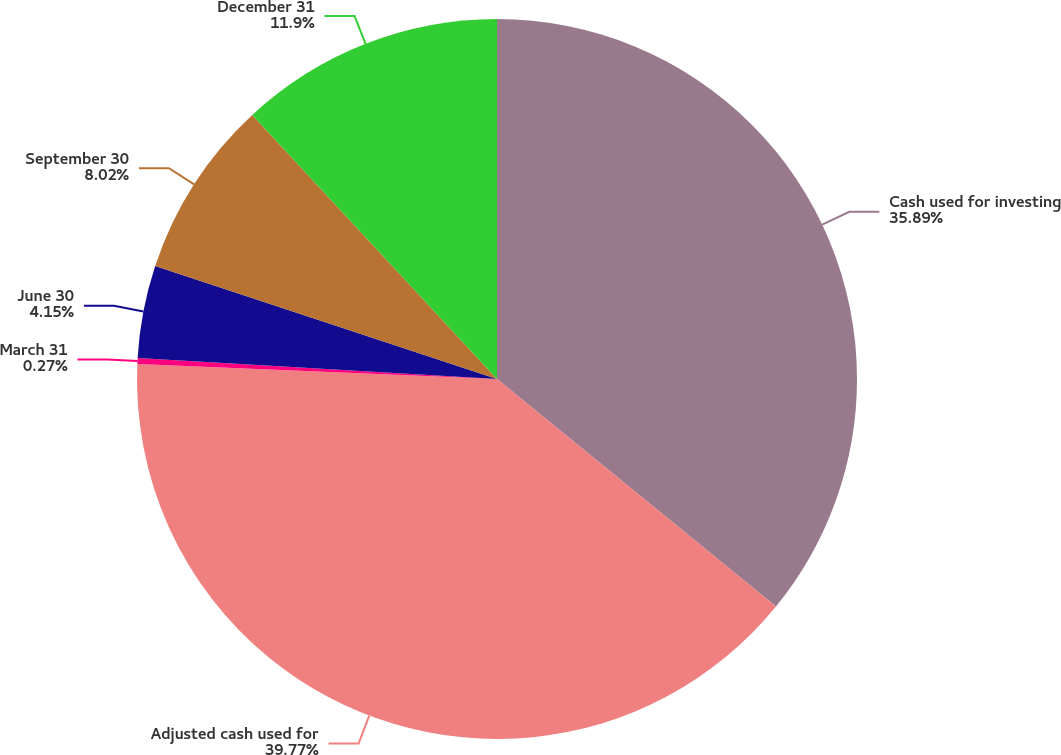Convert chart to OTSL. <chart><loc_0><loc_0><loc_500><loc_500><pie_chart><fcel>Cash used for investing<fcel>Adjusted cash used for<fcel>March 31<fcel>June 30<fcel>September 30<fcel>December 31<nl><fcel>35.89%<fcel>39.77%<fcel>0.27%<fcel>4.15%<fcel>8.02%<fcel>11.9%<nl></chart> 